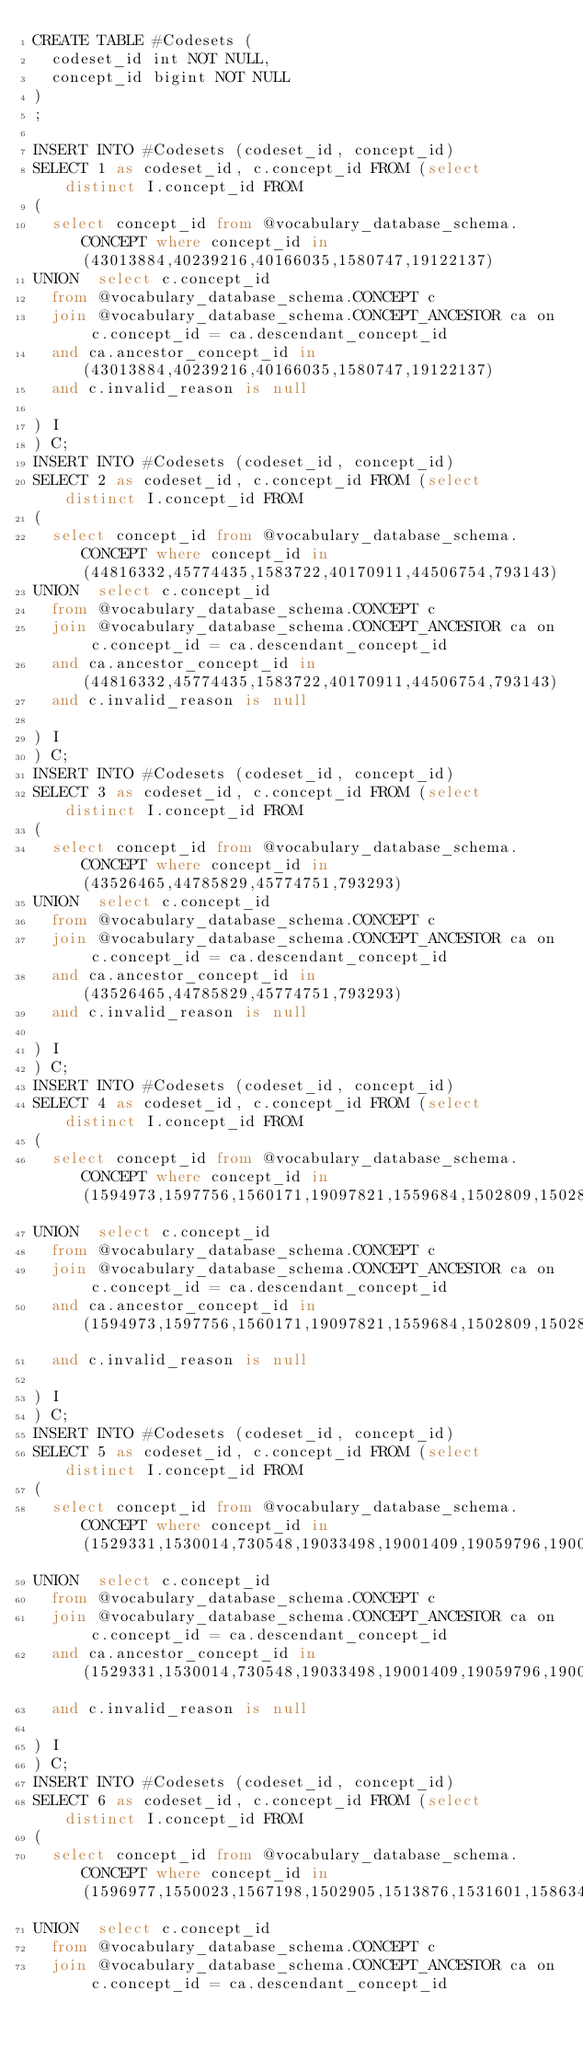<code> <loc_0><loc_0><loc_500><loc_500><_SQL_>CREATE TABLE #Codesets (
  codeset_id int NOT NULL,
  concept_id bigint NOT NULL
)
;

INSERT INTO #Codesets (codeset_id, concept_id)
SELECT 1 as codeset_id, c.concept_id FROM (select distinct I.concept_id FROM
( 
  select concept_id from @vocabulary_database_schema.CONCEPT where concept_id in (43013884,40239216,40166035,1580747,19122137)
UNION  select c.concept_id
  from @vocabulary_database_schema.CONCEPT c
  join @vocabulary_database_schema.CONCEPT_ANCESTOR ca on c.concept_id = ca.descendant_concept_id
  and ca.ancestor_concept_id in (43013884,40239216,40166035,1580747,19122137)
  and c.invalid_reason is null

) I
) C;
INSERT INTO #Codesets (codeset_id, concept_id)
SELECT 2 as codeset_id, c.concept_id FROM (select distinct I.concept_id FROM
( 
  select concept_id from @vocabulary_database_schema.CONCEPT where concept_id in (44816332,45774435,1583722,40170911,44506754,793143)
UNION  select c.concept_id
  from @vocabulary_database_schema.CONCEPT c
  join @vocabulary_database_schema.CONCEPT_ANCESTOR ca on c.concept_id = ca.descendant_concept_id
  and ca.ancestor_concept_id in (44816332,45774435,1583722,40170911,44506754,793143)
  and c.invalid_reason is null

) I
) C;
INSERT INTO #Codesets (codeset_id, concept_id)
SELECT 3 as codeset_id, c.concept_id FROM (select distinct I.concept_id FROM
( 
  select concept_id from @vocabulary_database_schema.CONCEPT where concept_id in (43526465,44785829,45774751,793293)
UNION  select c.concept_id
  from @vocabulary_database_schema.CONCEPT c
  join @vocabulary_database_schema.CONCEPT_ANCESTOR ca on c.concept_id = ca.descendant_concept_id
  and ca.ancestor_concept_id in (43526465,44785829,45774751,793293)
  and c.invalid_reason is null

) I
) C;
INSERT INTO #Codesets (codeset_id, concept_id)
SELECT 4 as codeset_id, c.concept_id FROM (select distinct I.concept_id FROM
( 
  select concept_id from @vocabulary_database_schema.CONCEPT where concept_id in (1594973,1597756,1560171,19097821,1559684,1502809,1502855)
UNION  select c.concept_id
  from @vocabulary_database_schema.CONCEPT c
  join @vocabulary_database_schema.CONCEPT_ANCESTOR ca on c.concept_id = ca.descendant_concept_id
  and ca.ancestor_concept_id in (1594973,1597756,1560171,19097821,1559684,1502809,1502855)
  and c.invalid_reason is null

) I
) C;
INSERT INTO #Codesets (codeset_id, concept_id)
SELECT 5 as codeset_id, c.concept_id FROM (select distinct I.concept_id FROM
( 
  select concept_id from @vocabulary_database_schema.CONCEPT where concept_id in (1529331,1530014,730548,19033498,19001409,19059796,19001441,1510202,1502826,1525215,1516766,1547504,1515249)
UNION  select c.concept_id
  from @vocabulary_database_schema.CONCEPT c
  join @vocabulary_database_schema.CONCEPT_ANCESTOR ca on c.concept_id = ca.descendant_concept_id
  and ca.ancestor_concept_id in (1529331,1530014,730548,19033498,19001409,19059796,19001441,1510202,1502826,1525215,1516766,1547504,1515249)
  and c.invalid_reason is null

) I
) C;
INSERT INTO #Codesets (codeset_id, concept_id)
SELECT 6 as codeset_id, c.concept_id FROM (select distinct I.concept_id FROM
( 
  select concept_id from @vocabulary_database_schema.CONCEPT where concept_id in (1596977,1550023,1567198,1502905,1513876,1531601,1586346,1544838,1516976,1590165,1513849,1562586,1588986,1513843,1586369,35605670,35602717,21600713,19078608)
UNION  select c.concept_id
  from @vocabulary_database_schema.CONCEPT c
  join @vocabulary_database_schema.CONCEPT_ANCESTOR ca on c.concept_id = ca.descendant_concept_id</code> 